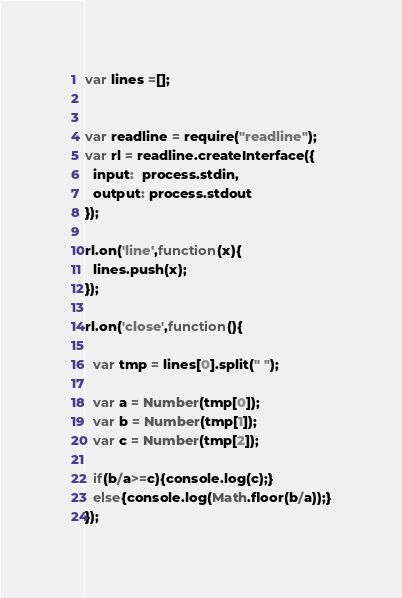<code> <loc_0><loc_0><loc_500><loc_500><_JavaScript_>var lines =[];


var readline = require("readline");
var rl = readline.createInterface({
  input:  process.stdin,
  output: process.stdout
});

rl.on('line',function(x){
  lines.push(x);
});

rl.on('close',function(){

  var tmp = lines[0].split(" ");
  
  var a = Number(tmp[0]);
  var b = Number(tmp[1]);
  var c = Number(tmp[2]);
  
  if(b/a>=c){console.log(c);}
  else{console.log(Math.floor(b/a));}
});</code> 